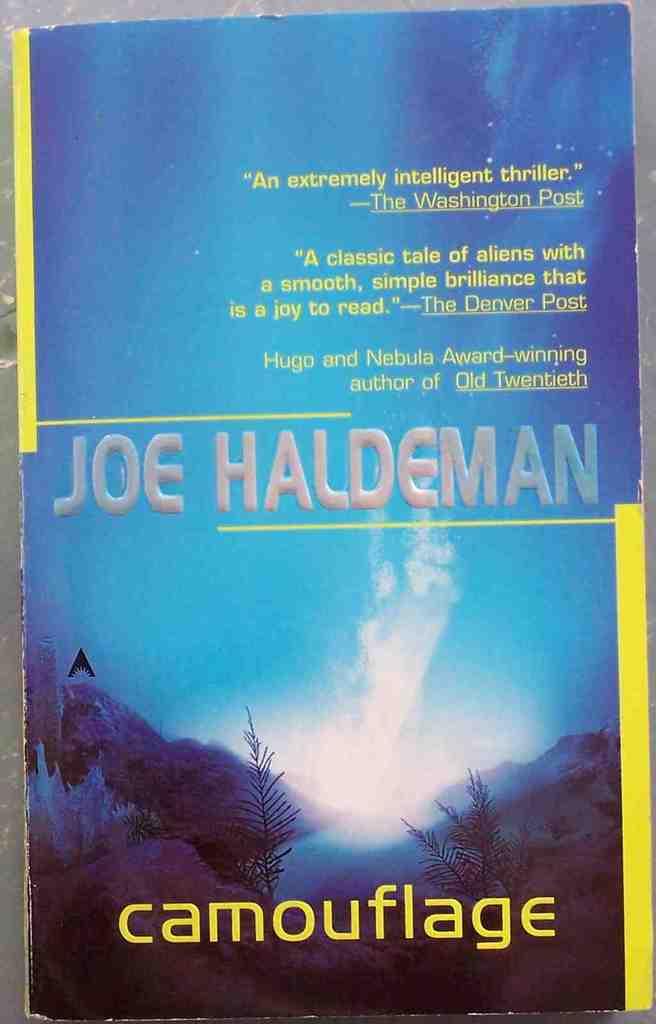Whats the name of the book?
Your answer should be compact. Camouflage. 